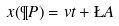Convert formula to latex. <formula><loc_0><loc_0><loc_500><loc_500>x ( \P P ) = v t + \L A</formula> 